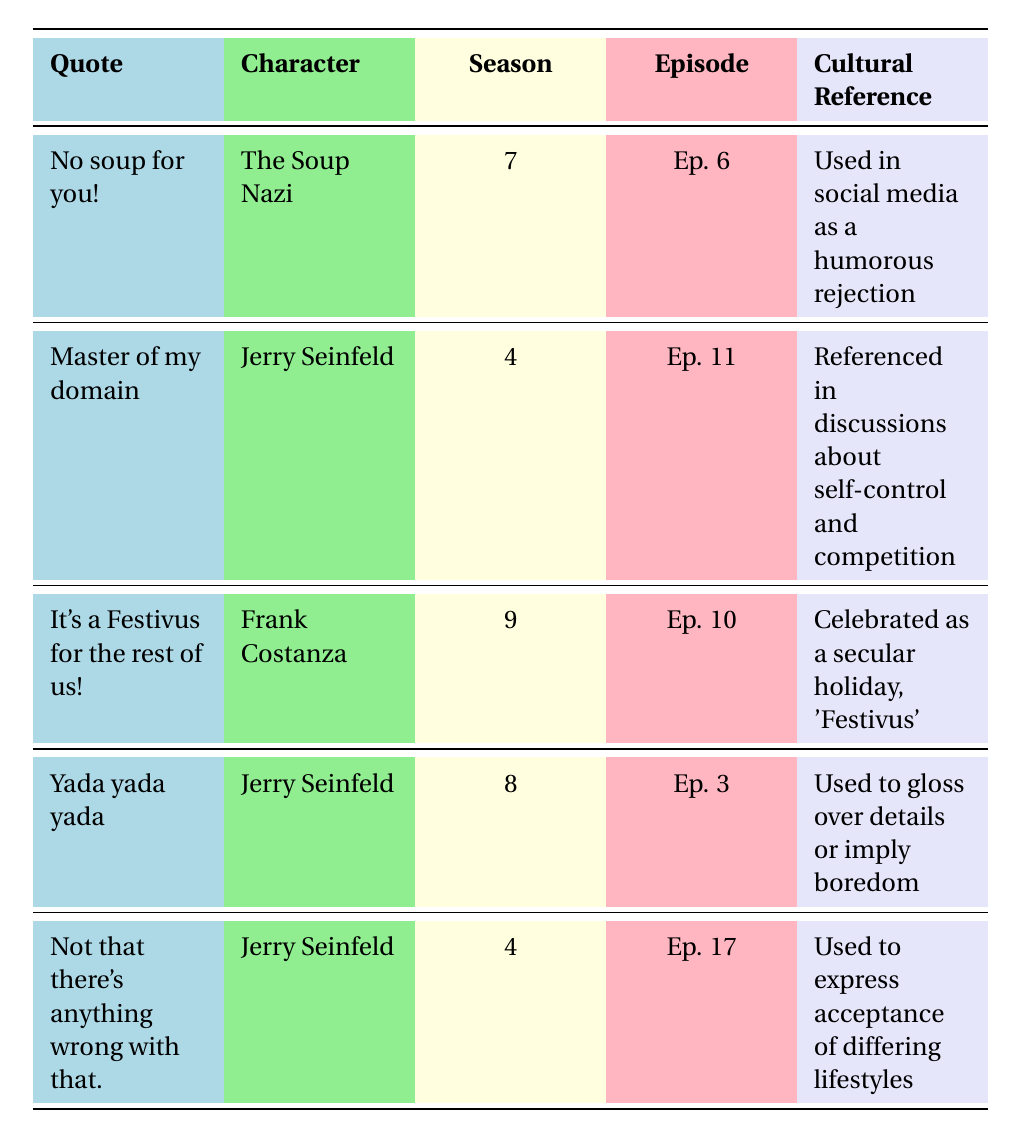What character says "No soup for you!"? According to the table, "No soup for you!" is said by The Soup Nazi.
Answer: The Soup Nazi In which season did the quote "Yada yada yada" appear? From the table, "Yada yada yada" appears in season 8.
Answer: Season 8 How many quotes are attributed to Jerry Seinfeld? There are three quotes attributed to Jerry Seinfeld: "Master of my domain," "Yada yada yada," and "Not that there's anything wrong with that."
Answer: Three What is the cultural reference associated with the quote "It's a Festivus for the rest of us!"? The cultural reference for "It's a Festivus for the rest of us!" is that it is celebrated as a secular holiday called 'Festivus'.
Answer: A secular holiday called 'Festivus' Which quote was referenced in discussions about self-control? "Master of my domain" is referenced in discussions about self-control and competition.
Answer: Master of my domain Is "Yada yada yada" used to imply boredom? Yes, the table states that "Yada yada yada" is used to gloss over details or imply boredom.
Answer: Yes What is the episode number for "Not that there's anything wrong with that."? The episode number for "Not that there's anything wrong with that." is Ep. 17, as indicated in the table.
Answer: Ep. 17 Which character appears in both the fourth and eighth seasons? The character Jerry Seinfeld appears in both the fourth and eighth seasons, as he has quotes listed for both.
Answer: Jerry Seinfeld What season has the most quotes listed in the table? The fourth season has the most quotes listed, with two quotes: "Master of my domain" and "Not that there's anything wrong with that."
Answer: Season 4 